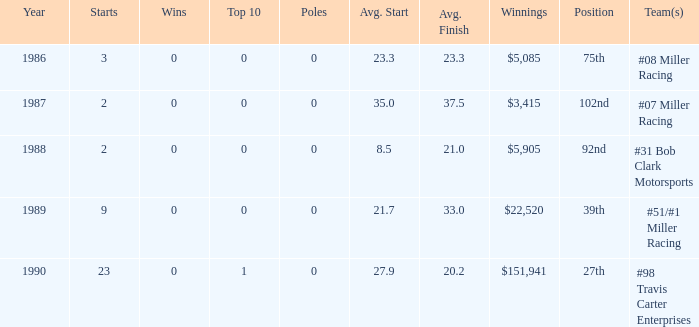In the #08 miller racing, what are the poles? 0.0. 